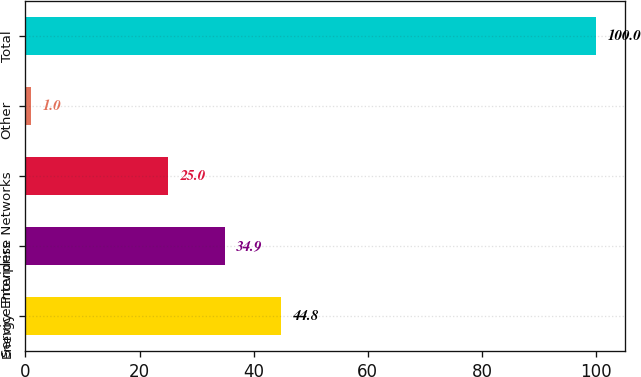<chart> <loc_0><loc_0><loc_500><loc_500><bar_chart><fcel>Energy<fcel>Service Providers<fcel>Enterprise Networks<fcel>Other<fcel>Total<nl><fcel>44.8<fcel>34.9<fcel>25<fcel>1<fcel>100<nl></chart> 